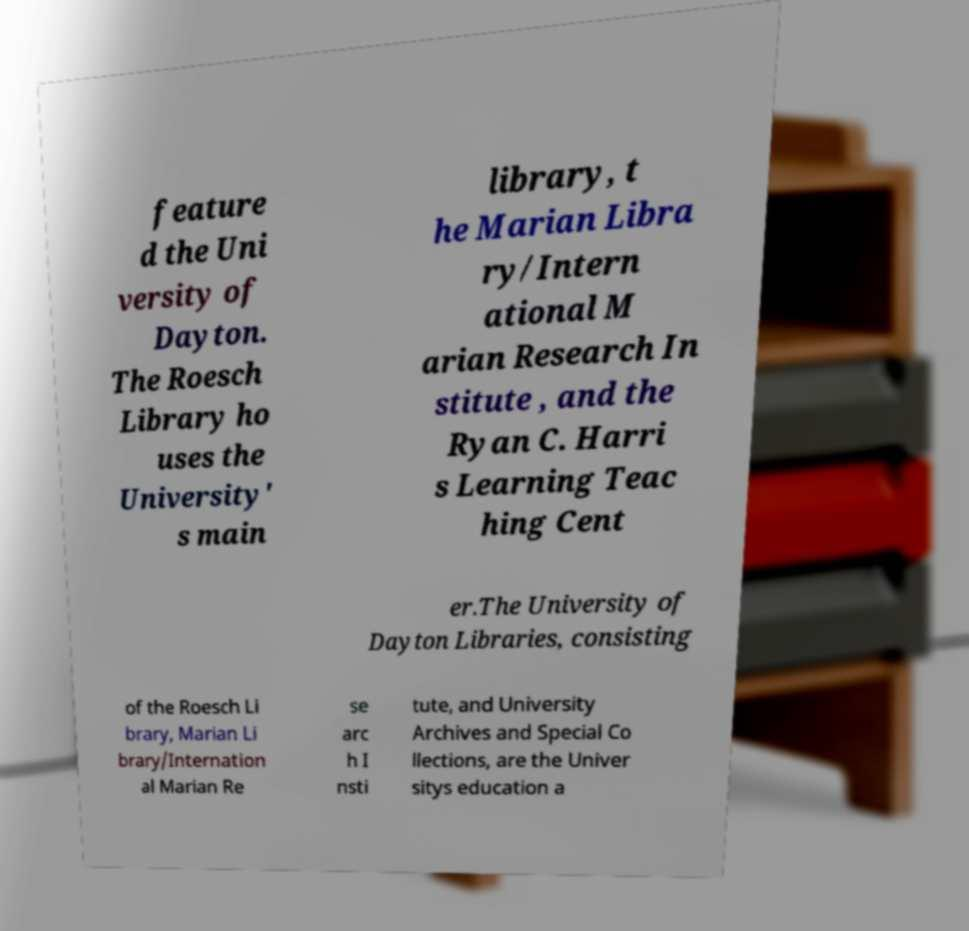Could you extract and type out the text from this image? feature d the Uni versity of Dayton. The Roesch Library ho uses the University' s main library, t he Marian Libra ry/Intern ational M arian Research In stitute , and the Ryan C. Harri s Learning Teac hing Cent er.The University of Dayton Libraries, consisting of the Roesch Li brary, Marian Li brary/Internation al Marian Re se arc h I nsti tute, and University Archives and Special Co llections, are the Univer sitys education a 